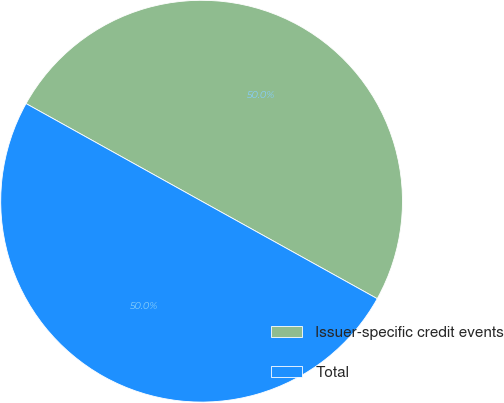Convert chart to OTSL. <chart><loc_0><loc_0><loc_500><loc_500><pie_chart><fcel>Issuer-specific credit events<fcel>Total<nl><fcel>49.99%<fcel>50.01%<nl></chart> 